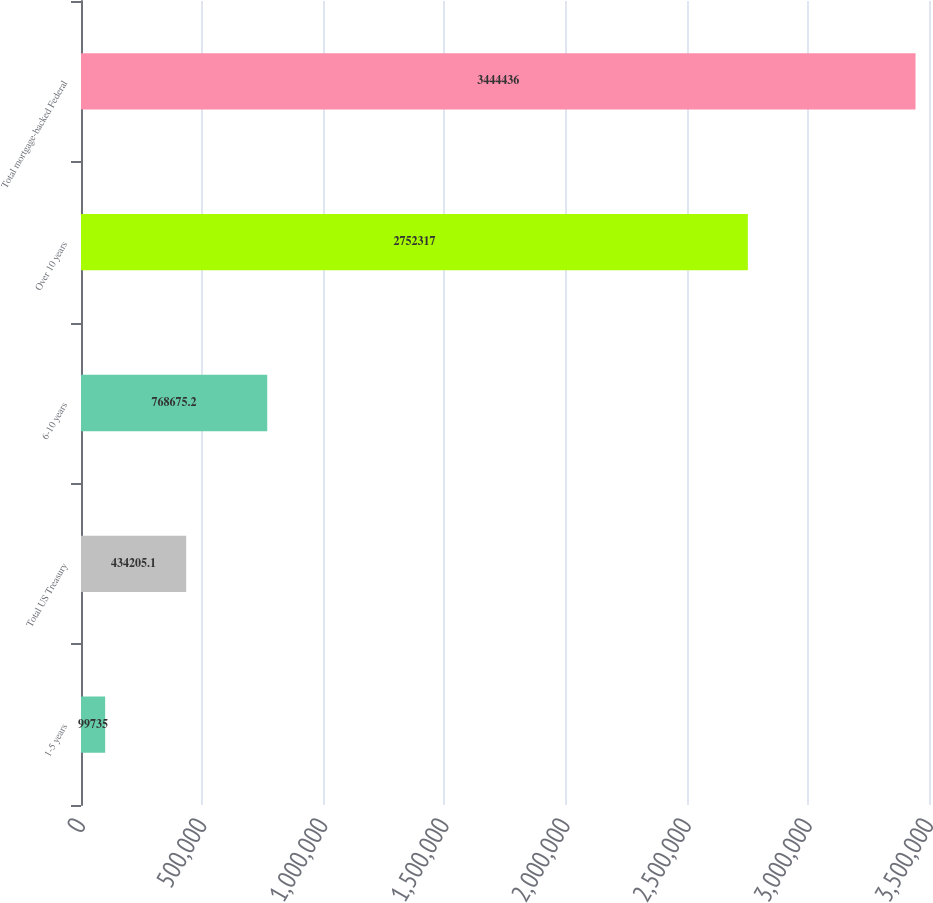Convert chart to OTSL. <chart><loc_0><loc_0><loc_500><loc_500><bar_chart><fcel>1-5 years<fcel>Total US Treasury<fcel>6-10 years<fcel>Over 10 years<fcel>Total mortgage-backed Federal<nl><fcel>99735<fcel>434205<fcel>768675<fcel>2.75232e+06<fcel>3.44444e+06<nl></chart> 